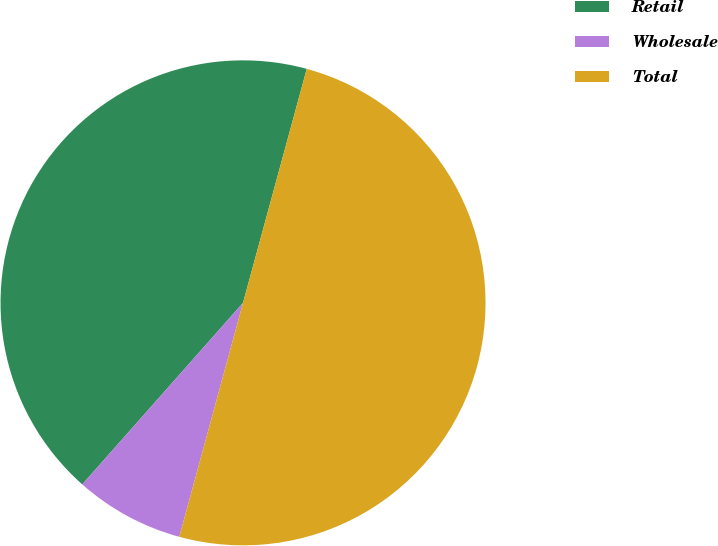<chart> <loc_0><loc_0><loc_500><loc_500><pie_chart><fcel>Retail<fcel>Wholesale<fcel>Total<nl><fcel>42.7%<fcel>7.3%<fcel>50.0%<nl></chart> 